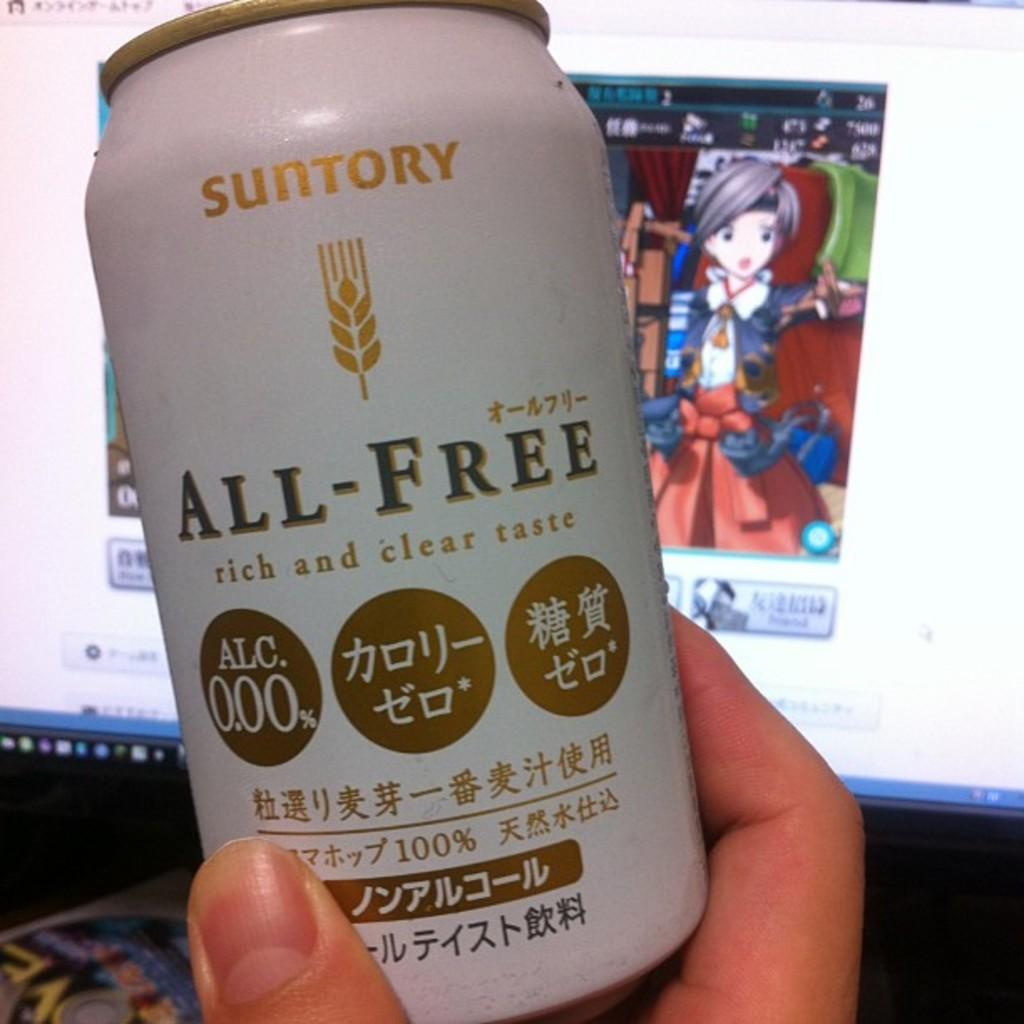What is the main subject in the foreground of the image? There is a person in the foreground of the image. What is the person holding in their hand? The person is holding a can with some text. What can be seen on the screen in the background? There is a screen with an animated picture in the background. What object is placed on a surface in the background? There is a disk placed on a surface in the background. What type of throat medicine is the person taking in the image? There is no indication in the image that the person is taking any throat medicine. 